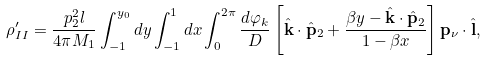Convert formula to latex. <formula><loc_0><loc_0><loc_500><loc_500>\rho _ { I I } ^ { \prime } = \frac { p _ { 2 } ^ { 2 } l } { 4 \pi M _ { 1 } } \int _ { - 1 } ^ { y _ { 0 } } d y \int _ { - 1 } ^ { 1 } d x \int _ { 0 } ^ { 2 \pi } \frac { d \varphi _ { k } } { D } \left [ { \hat { \mathbf k } } \cdot { \hat { \mathbf p } _ { 2 } } + \frac { \beta y - { \hat { \mathbf k } } \cdot { \hat { \mathbf p } _ { 2 } } } { 1 - \beta x } \right ] { \mathbf p } _ { \nu } \cdot { \hat { \mathbf l } } ,</formula> 